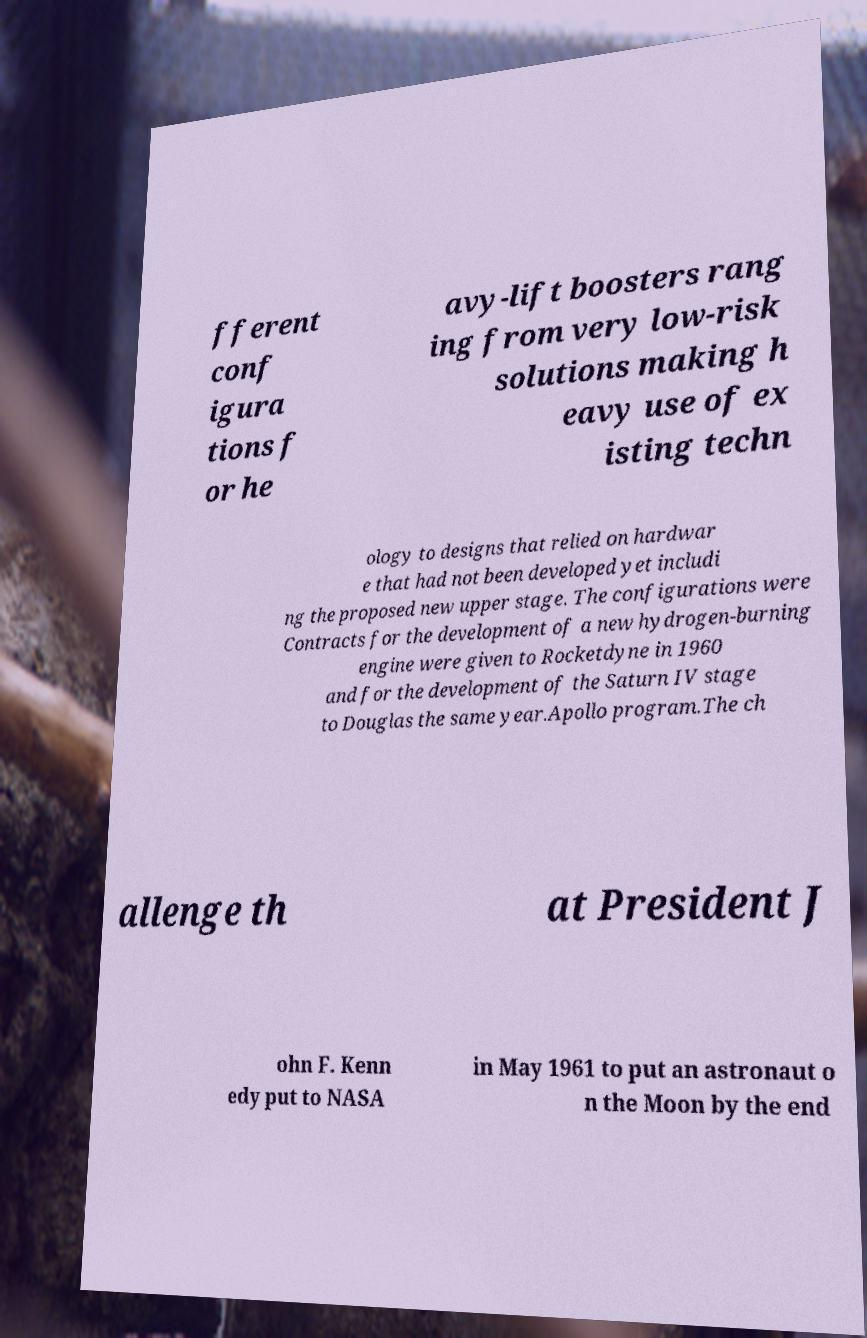Please identify and transcribe the text found in this image. fferent conf igura tions f or he avy-lift boosters rang ing from very low-risk solutions making h eavy use of ex isting techn ology to designs that relied on hardwar e that had not been developed yet includi ng the proposed new upper stage. The configurations were Contracts for the development of a new hydrogen-burning engine were given to Rocketdyne in 1960 and for the development of the Saturn IV stage to Douglas the same year.Apollo program.The ch allenge th at President J ohn F. Kenn edy put to NASA in May 1961 to put an astronaut o n the Moon by the end 